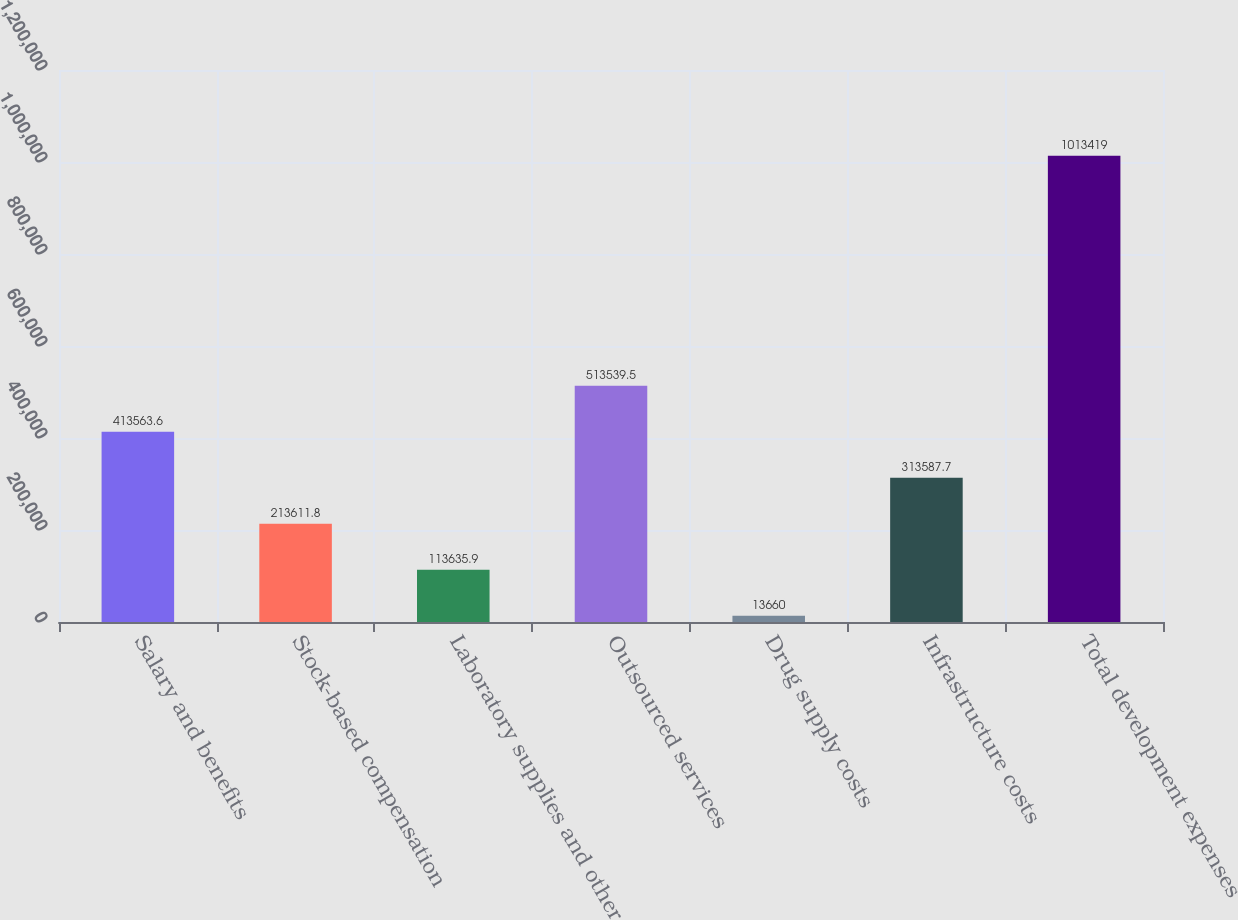Convert chart. <chart><loc_0><loc_0><loc_500><loc_500><bar_chart><fcel>Salary and benefits<fcel>Stock-based compensation<fcel>Laboratory supplies and other<fcel>Outsourced services<fcel>Drug supply costs<fcel>Infrastructure costs<fcel>Total development expenses<nl><fcel>413564<fcel>213612<fcel>113636<fcel>513540<fcel>13660<fcel>313588<fcel>1.01342e+06<nl></chart> 